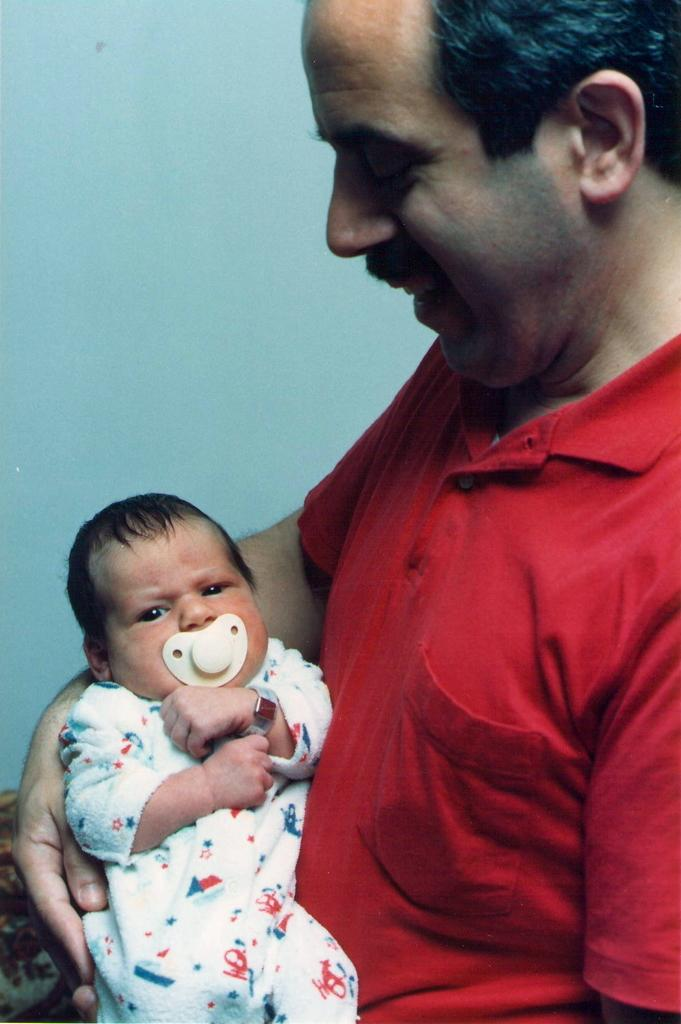Who is the main subject in the image? There is a man in the image. What is the man wearing? The man is wearing a red t-shirt. What is the man doing in the image? The man is holding a baby. What is the man's facial expression? The man is smiling. What color is the background wall in the image? The background wall is blue. What type of sock is the kitten wearing in the image? There is no kitten or sock present in the image. Is the door open or closed in the image? There is no door visible in the image. 